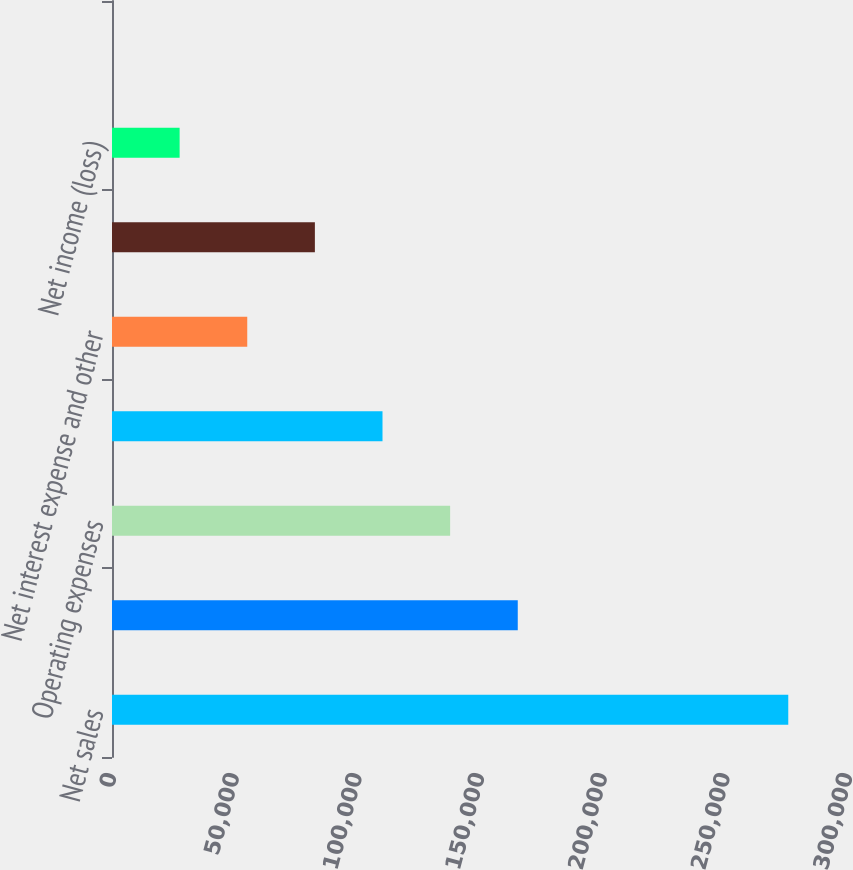Convert chart to OTSL. <chart><loc_0><loc_0><loc_500><loc_500><bar_chart><fcel>Net sales<fcel>Gross profit<fcel>Operating expenses<fcel>Operating income<fcel>Net interest expense and other<fcel>Remeasurements and other (2)<fcel>Net income (loss)<fcel>Diluted earnings (loss) per<nl><fcel>275653<fcel>165392<fcel>137827<fcel>110261<fcel>55130.6<fcel>82695.9<fcel>27565.3<fcel>0.01<nl></chart> 